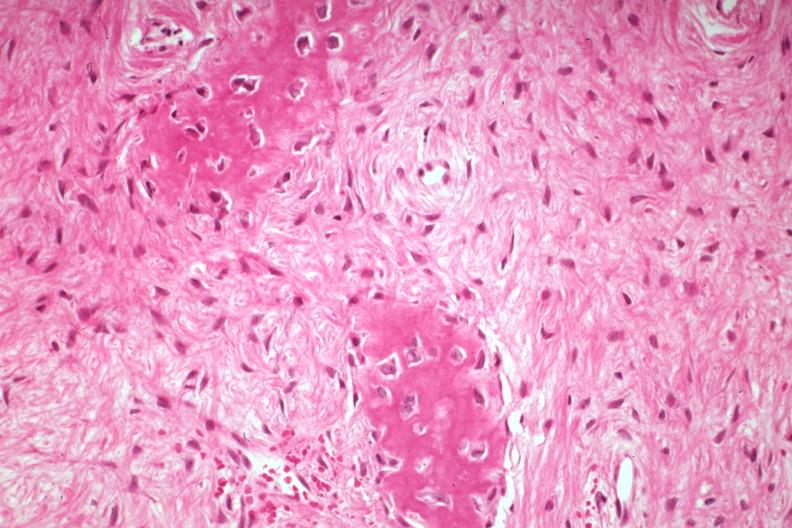what does this image show?
Answer the question using a single word or phrase. High excessive fibrous callus in a non-union excellent granulation type tissue with collagen 